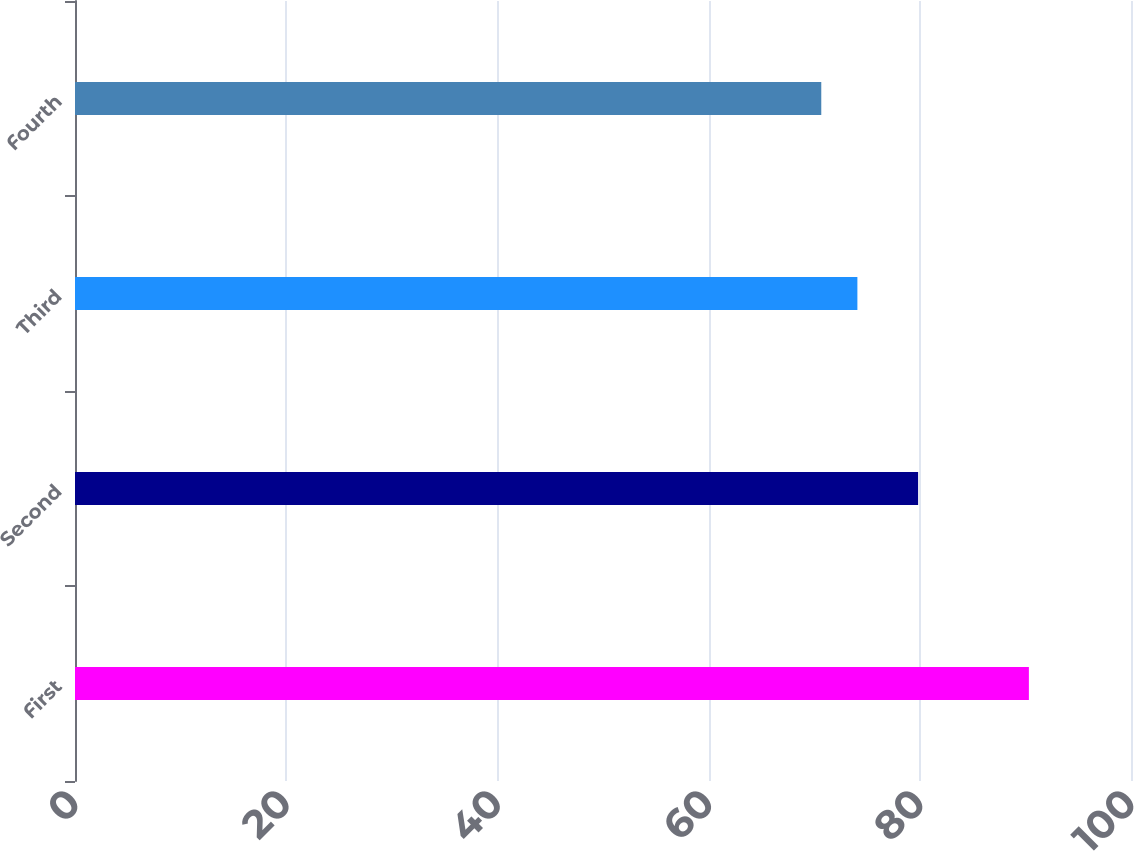Convert chart to OTSL. <chart><loc_0><loc_0><loc_500><loc_500><bar_chart><fcel>First<fcel>Second<fcel>Third<fcel>Fourth<nl><fcel>90.33<fcel>79.84<fcel>74.09<fcel>70.67<nl></chart> 